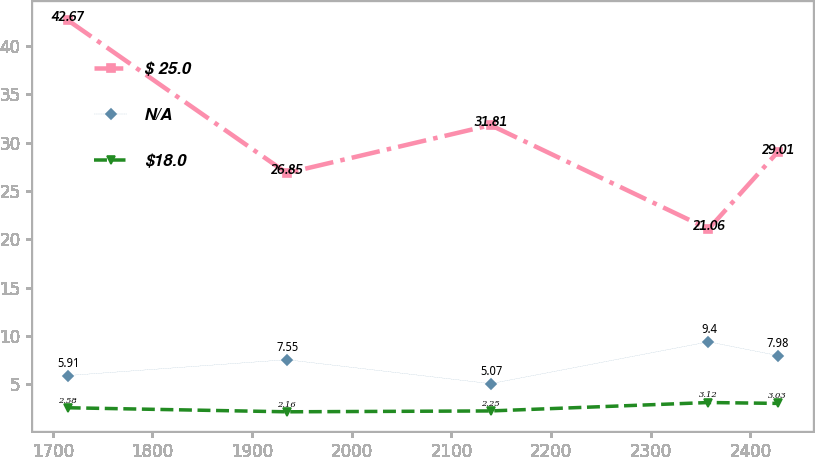Convert chart. <chart><loc_0><loc_0><loc_500><loc_500><line_chart><ecel><fcel>$ 25.0<fcel>N/A<fcel>$18.0<nl><fcel>1714.89<fcel>42.67<fcel>5.91<fcel>2.58<nl><fcel>1934.68<fcel>26.85<fcel>7.55<fcel>2.16<nl><fcel>2139.34<fcel>31.81<fcel>5.07<fcel>2.25<nl><fcel>2357.97<fcel>21.06<fcel>9.4<fcel>3.12<nl><fcel>2427.3<fcel>29.01<fcel>7.98<fcel>3.03<nl></chart> 